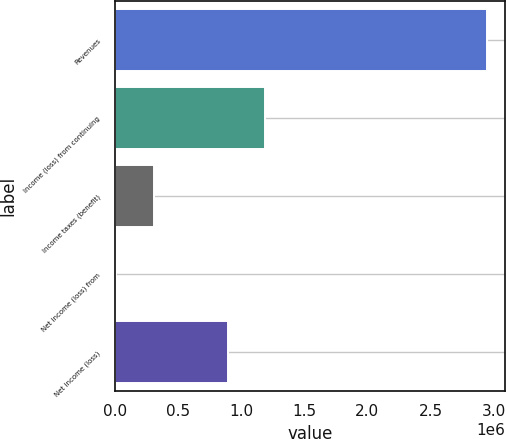Convert chart. <chart><loc_0><loc_0><loc_500><loc_500><bar_chart><fcel>Revenues<fcel>Income (loss) from continuing<fcel>Income taxes (benefit)<fcel>Net income (loss) from<fcel>Net income (loss)<nl><fcel>2.94498e+06<fcel>1.18613e+06<fcel>306705<fcel>13563<fcel>892988<nl></chart> 